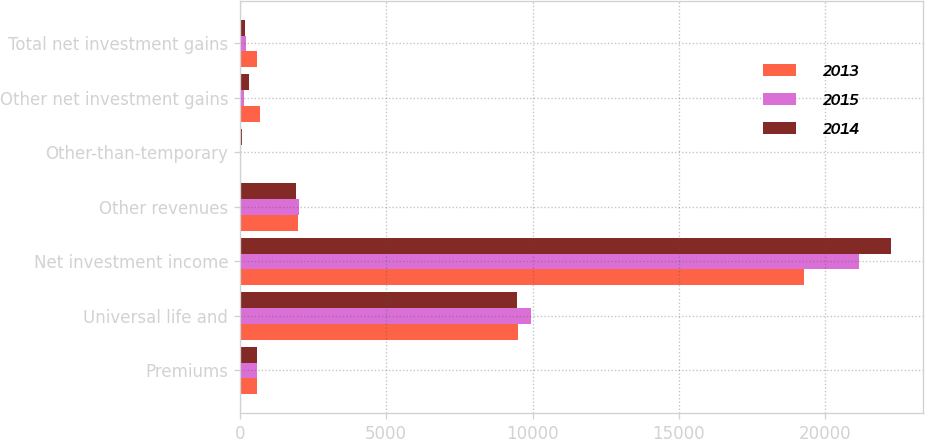Convert chart to OTSL. <chart><loc_0><loc_0><loc_500><loc_500><stacked_bar_chart><ecel><fcel>Premiums<fcel>Universal life and<fcel>Net investment income<fcel>Other revenues<fcel>Other-than-temporary<fcel>Other net investment gains<fcel>Total net investment gains<nl><fcel>2013<fcel>597<fcel>9507<fcel>19281<fcel>1983<fcel>6<fcel>687<fcel>597<nl><fcel>2015<fcel>597<fcel>9946<fcel>21153<fcel>2030<fcel>17<fcel>137<fcel>197<nl><fcel>2014<fcel>597<fcel>9451<fcel>22232<fcel>1920<fcel>60<fcel>327<fcel>161<nl></chart> 